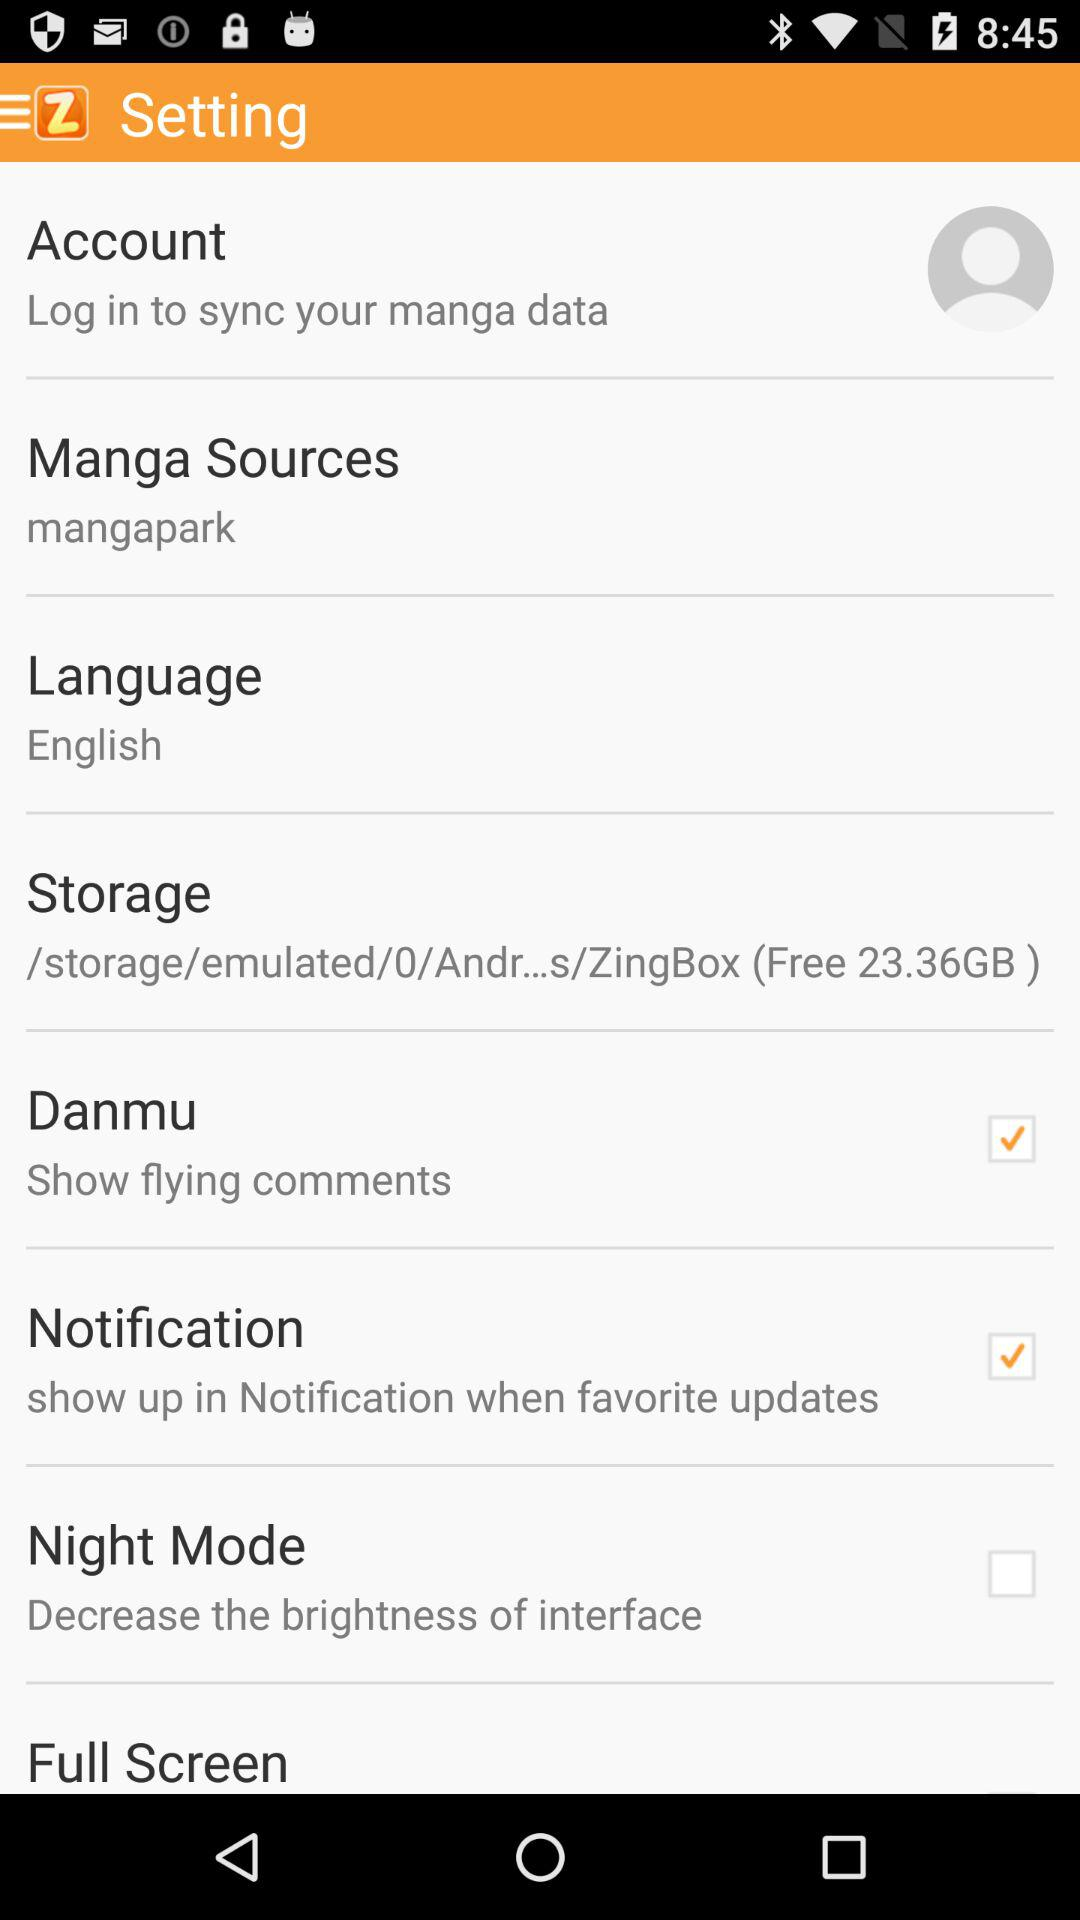What are the "Manga Sources"? The "Manga Sources" are "mangapark". 